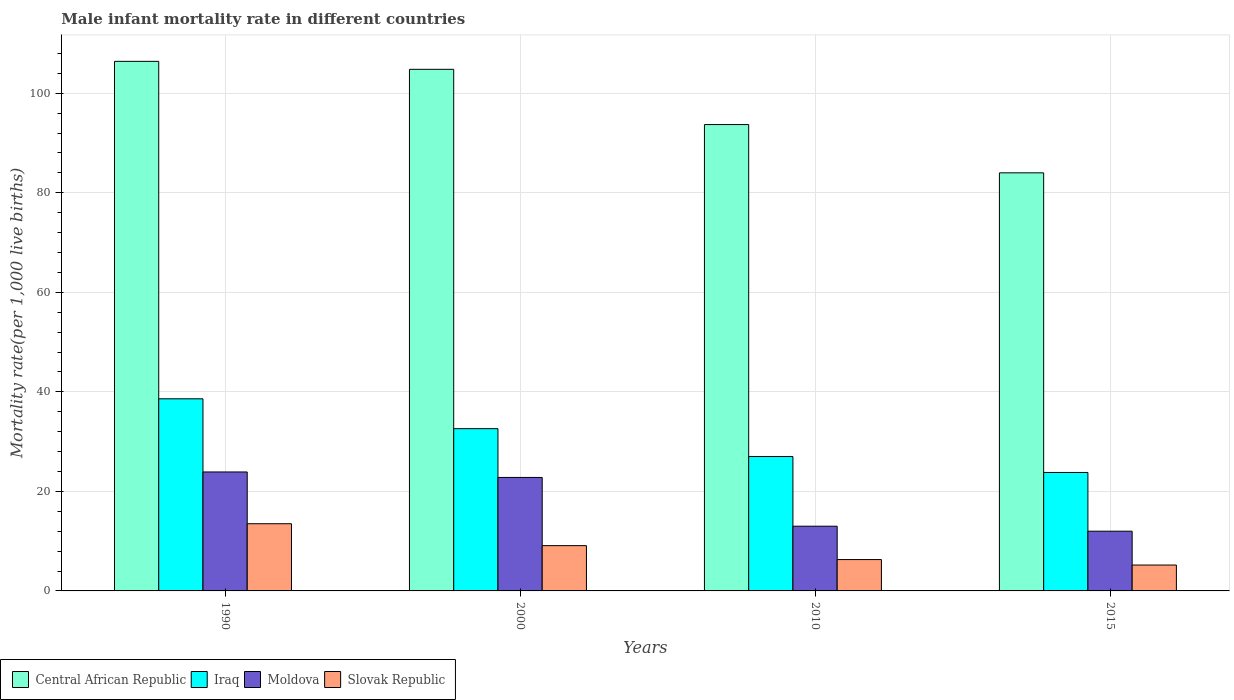How many groups of bars are there?
Your answer should be compact. 4. Are the number of bars per tick equal to the number of legend labels?
Keep it short and to the point. Yes. Are the number of bars on each tick of the X-axis equal?
Your answer should be compact. Yes. Across all years, what is the maximum male infant mortality rate in Moldova?
Your answer should be compact. 23.9. Across all years, what is the minimum male infant mortality rate in Iraq?
Offer a terse response. 23.8. In which year was the male infant mortality rate in Moldova minimum?
Provide a short and direct response. 2015. What is the total male infant mortality rate in Central African Republic in the graph?
Offer a very short reply. 388.9. What is the difference between the male infant mortality rate in Central African Republic in 2015 and the male infant mortality rate in Iraq in 1990?
Provide a short and direct response. 45.4. What is the average male infant mortality rate in Slovak Republic per year?
Your answer should be compact. 8.53. In the year 2010, what is the difference between the male infant mortality rate in Slovak Republic and male infant mortality rate in Moldova?
Your answer should be compact. -6.7. What is the ratio of the male infant mortality rate in Iraq in 1990 to that in 2000?
Your answer should be compact. 1.18. Is the male infant mortality rate in Central African Republic in 1990 less than that in 2000?
Your answer should be compact. No. What does the 2nd bar from the left in 1990 represents?
Ensure brevity in your answer.  Iraq. What does the 1st bar from the right in 1990 represents?
Ensure brevity in your answer.  Slovak Republic. Is it the case that in every year, the sum of the male infant mortality rate in Iraq and male infant mortality rate in Slovak Republic is greater than the male infant mortality rate in Central African Republic?
Ensure brevity in your answer.  No. How many bars are there?
Your answer should be very brief. 16. Are all the bars in the graph horizontal?
Ensure brevity in your answer.  No. How many years are there in the graph?
Offer a very short reply. 4. Are the values on the major ticks of Y-axis written in scientific E-notation?
Offer a terse response. No. Does the graph contain any zero values?
Ensure brevity in your answer.  No. Where does the legend appear in the graph?
Provide a succinct answer. Bottom left. How are the legend labels stacked?
Offer a terse response. Horizontal. What is the title of the graph?
Offer a very short reply. Male infant mortality rate in different countries. What is the label or title of the X-axis?
Provide a short and direct response. Years. What is the label or title of the Y-axis?
Offer a very short reply. Mortality rate(per 1,0 live births). What is the Mortality rate(per 1,000 live births) in Central African Republic in 1990?
Ensure brevity in your answer.  106.4. What is the Mortality rate(per 1,000 live births) of Iraq in 1990?
Ensure brevity in your answer.  38.6. What is the Mortality rate(per 1,000 live births) of Moldova in 1990?
Offer a terse response. 23.9. What is the Mortality rate(per 1,000 live births) in Central African Republic in 2000?
Your response must be concise. 104.8. What is the Mortality rate(per 1,000 live births) in Iraq in 2000?
Keep it short and to the point. 32.6. What is the Mortality rate(per 1,000 live births) in Moldova in 2000?
Ensure brevity in your answer.  22.8. What is the Mortality rate(per 1,000 live births) of Central African Republic in 2010?
Your response must be concise. 93.7. What is the Mortality rate(per 1,000 live births) in Iraq in 2010?
Your answer should be very brief. 27. What is the Mortality rate(per 1,000 live births) in Moldova in 2010?
Your answer should be very brief. 13. What is the Mortality rate(per 1,000 live births) of Central African Republic in 2015?
Offer a very short reply. 84. What is the Mortality rate(per 1,000 live births) in Iraq in 2015?
Make the answer very short. 23.8. What is the Mortality rate(per 1,000 live births) of Moldova in 2015?
Ensure brevity in your answer.  12. Across all years, what is the maximum Mortality rate(per 1,000 live births) in Central African Republic?
Your answer should be very brief. 106.4. Across all years, what is the maximum Mortality rate(per 1,000 live births) in Iraq?
Give a very brief answer. 38.6. Across all years, what is the maximum Mortality rate(per 1,000 live births) in Moldova?
Offer a very short reply. 23.9. Across all years, what is the maximum Mortality rate(per 1,000 live births) of Slovak Republic?
Keep it short and to the point. 13.5. Across all years, what is the minimum Mortality rate(per 1,000 live births) in Iraq?
Offer a terse response. 23.8. What is the total Mortality rate(per 1,000 live births) in Central African Republic in the graph?
Offer a terse response. 388.9. What is the total Mortality rate(per 1,000 live births) in Iraq in the graph?
Keep it short and to the point. 122. What is the total Mortality rate(per 1,000 live births) of Moldova in the graph?
Make the answer very short. 71.7. What is the total Mortality rate(per 1,000 live births) in Slovak Republic in the graph?
Ensure brevity in your answer.  34.1. What is the difference between the Mortality rate(per 1,000 live births) of Central African Republic in 1990 and that in 2000?
Ensure brevity in your answer.  1.6. What is the difference between the Mortality rate(per 1,000 live births) in Moldova in 1990 and that in 2000?
Your answer should be compact. 1.1. What is the difference between the Mortality rate(per 1,000 live births) of Central African Republic in 1990 and that in 2010?
Provide a short and direct response. 12.7. What is the difference between the Mortality rate(per 1,000 live births) in Moldova in 1990 and that in 2010?
Make the answer very short. 10.9. What is the difference between the Mortality rate(per 1,000 live births) in Slovak Republic in 1990 and that in 2010?
Keep it short and to the point. 7.2. What is the difference between the Mortality rate(per 1,000 live births) of Central African Republic in 1990 and that in 2015?
Give a very brief answer. 22.4. What is the difference between the Mortality rate(per 1,000 live births) of Central African Republic in 2000 and that in 2010?
Offer a terse response. 11.1. What is the difference between the Mortality rate(per 1,000 live births) in Slovak Republic in 2000 and that in 2010?
Provide a succinct answer. 2.8. What is the difference between the Mortality rate(per 1,000 live births) of Central African Republic in 2000 and that in 2015?
Provide a short and direct response. 20.8. What is the difference between the Mortality rate(per 1,000 live births) of Iraq in 2000 and that in 2015?
Your answer should be compact. 8.8. What is the difference between the Mortality rate(per 1,000 live births) of Slovak Republic in 2000 and that in 2015?
Provide a succinct answer. 3.9. What is the difference between the Mortality rate(per 1,000 live births) of Moldova in 2010 and that in 2015?
Make the answer very short. 1. What is the difference between the Mortality rate(per 1,000 live births) in Slovak Republic in 2010 and that in 2015?
Your answer should be very brief. 1.1. What is the difference between the Mortality rate(per 1,000 live births) in Central African Republic in 1990 and the Mortality rate(per 1,000 live births) in Iraq in 2000?
Give a very brief answer. 73.8. What is the difference between the Mortality rate(per 1,000 live births) in Central African Republic in 1990 and the Mortality rate(per 1,000 live births) in Moldova in 2000?
Offer a very short reply. 83.6. What is the difference between the Mortality rate(per 1,000 live births) of Central African Republic in 1990 and the Mortality rate(per 1,000 live births) of Slovak Republic in 2000?
Make the answer very short. 97.3. What is the difference between the Mortality rate(per 1,000 live births) in Iraq in 1990 and the Mortality rate(per 1,000 live births) in Moldova in 2000?
Offer a terse response. 15.8. What is the difference between the Mortality rate(per 1,000 live births) of Iraq in 1990 and the Mortality rate(per 1,000 live births) of Slovak Republic in 2000?
Your answer should be compact. 29.5. What is the difference between the Mortality rate(per 1,000 live births) in Central African Republic in 1990 and the Mortality rate(per 1,000 live births) in Iraq in 2010?
Your answer should be compact. 79.4. What is the difference between the Mortality rate(per 1,000 live births) of Central African Republic in 1990 and the Mortality rate(per 1,000 live births) of Moldova in 2010?
Offer a very short reply. 93.4. What is the difference between the Mortality rate(per 1,000 live births) in Central African Republic in 1990 and the Mortality rate(per 1,000 live births) in Slovak Republic in 2010?
Provide a succinct answer. 100.1. What is the difference between the Mortality rate(per 1,000 live births) in Iraq in 1990 and the Mortality rate(per 1,000 live births) in Moldova in 2010?
Provide a succinct answer. 25.6. What is the difference between the Mortality rate(per 1,000 live births) in Iraq in 1990 and the Mortality rate(per 1,000 live births) in Slovak Republic in 2010?
Give a very brief answer. 32.3. What is the difference between the Mortality rate(per 1,000 live births) of Moldova in 1990 and the Mortality rate(per 1,000 live births) of Slovak Republic in 2010?
Make the answer very short. 17.6. What is the difference between the Mortality rate(per 1,000 live births) of Central African Republic in 1990 and the Mortality rate(per 1,000 live births) of Iraq in 2015?
Make the answer very short. 82.6. What is the difference between the Mortality rate(per 1,000 live births) of Central African Republic in 1990 and the Mortality rate(per 1,000 live births) of Moldova in 2015?
Keep it short and to the point. 94.4. What is the difference between the Mortality rate(per 1,000 live births) in Central African Republic in 1990 and the Mortality rate(per 1,000 live births) in Slovak Republic in 2015?
Your answer should be compact. 101.2. What is the difference between the Mortality rate(per 1,000 live births) of Iraq in 1990 and the Mortality rate(per 1,000 live births) of Moldova in 2015?
Provide a succinct answer. 26.6. What is the difference between the Mortality rate(per 1,000 live births) in Iraq in 1990 and the Mortality rate(per 1,000 live births) in Slovak Republic in 2015?
Offer a terse response. 33.4. What is the difference between the Mortality rate(per 1,000 live births) in Moldova in 1990 and the Mortality rate(per 1,000 live births) in Slovak Republic in 2015?
Offer a terse response. 18.7. What is the difference between the Mortality rate(per 1,000 live births) of Central African Republic in 2000 and the Mortality rate(per 1,000 live births) of Iraq in 2010?
Your answer should be compact. 77.8. What is the difference between the Mortality rate(per 1,000 live births) of Central African Republic in 2000 and the Mortality rate(per 1,000 live births) of Moldova in 2010?
Give a very brief answer. 91.8. What is the difference between the Mortality rate(per 1,000 live births) in Central African Republic in 2000 and the Mortality rate(per 1,000 live births) in Slovak Republic in 2010?
Your response must be concise. 98.5. What is the difference between the Mortality rate(per 1,000 live births) in Iraq in 2000 and the Mortality rate(per 1,000 live births) in Moldova in 2010?
Your answer should be compact. 19.6. What is the difference between the Mortality rate(per 1,000 live births) of Iraq in 2000 and the Mortality rate(per 1,000 live births) of Slovak Republic in 2010?
Give a very brief answer. 26.3. What is the difference between the Mortality rate(per 1,000 live births) of Central African Republic in 2000 and the Mortality rate(per 1,000 live births) of Iraq in 2015?
Provide a short and direct response. 81. What is the difference between the Mortality rate(per 1,000 live births) in Central African Republic in 2000 and the Mortality rate(per 1,000 live births) in Moldova in 2015?
Provide a succinct answer. 92.8. What is the difference between the Mortality rate(per 1,000 live births) in Central African Republic in 2000 and the Mortality rate(per 1,000 live births) in Slovak Republic in 2015?
Make the answer very short. 99.6. What is the difference between the Mortality rate(per 1,000 live births) in Iraq in 2000 and the Mortality rate(per 1,000 live births) in Moldova in 2015?
Give a very brief answer. 20.6. What is the difference between the Mortality rate(per 1,000 live births) of Iraq in 2000 and the Mortality rate(per 1,000 live births) of Slovak Republic in 2015?
Offer a very short reply. 27.4. What is the difference between the Mortality rate(per 1,000 live births) of Moldova in 2000 and the Mortality rate(per 1,000 live births) of Slovak Republic in 2015?
Keep it short and to the point. 17.6. What is the difference between the Mortality rate(per 1,000 live births) of Central African Republic in 2010 and the Mortality rate(per 1,000 live births) of Iraq in 2015?
Give a very brief answer. 69.9. What is the difference between the Mortality rate(per 1,000 live births) of Central African Republic in 2010 and the Mortality rate(per 1,000 live births) of Moldova in 2015?
Give a very brief answer. 81.7. What is the difference between the Mortality rate(per 1,000 live births) in Central African Republic in 2010 and the Mortality rate(per 1,000 live births) in Slovak Republic in 2015?
Ensure brevity in your answer.  88.5. What is the difference between the Mortality rate(per 1,000 live births) in Iraq in 2010 and the Mortality rate(per 1,000 live births) in Slovak Republic in 2015?
Give a very brief answer. 21.8. What is the average Mortality rate(per 1,000 live births) in Central African Republic per year?
Offer a very short reply. 97.22. What is the average Mortality rate(per 1,000 live births) in Iraq per year?
Provide a succinct answer. 30.5. What is the average Mortality rate(per 1,000 live births) in Moldova per year?
Give a very brief answer. 17.93. What is the average Mortality rate(per 1,000 live births) of Slovak Republic per year?
Keep it short and to the point. 8.53. In the year 1990, what is the difference between the Mortality rate(per 1,000 live births) of Central African Republic and Mortality rate(per 1,000 live births) of Iraq?
Give a very brief answer. 67.8. In the year 1990, what is the difference between the Mortality rate(per 1,000 live births) in Central African Republic and Mortality rate(per 1,000 live births) in Moldova?
Ensure brevity in your answer.  82.5. In the year 1990, what is the difference between the Mortality rate(per 1,000 live births) in Central African Republic and Mortality rate(per 1,000 live births) in Slovak Republic?
Provide a short and direct response. 92.9. In the year 1990, what is the difference between the Mortality rate(per 1,000 live births) of Iraq and Mortality rate(per 1,000 live births) of Slovak Republic?
Offer a very short reply. 25.1. In the year 2000, what is the difference between the Mortality rate(per 1,000 live births) of Central African Republic and Mortality rate(per 1,000 live births) of Iraq?
Provide a succinct answer. 72.2. In the year 2000, what is the difference between the Mortality rate(per 1,000 live births) in Central African Republic and Mortality rate(per 1,000 live births) in Slovak Republic?
Provide a short and direct response. 95.7. In the year 2000, what is the difference between the Mortality rate(per 1,000 live births) in Iraq and Mortality rate(per 1,000 live births) in Moldova?
Offer a terse response. 9.8. In the year 2010, what is the difference between the Mortality rate(per 1,000 live births) in Central African Republic and Mortality rate(per 1,000 live births) in Iraq?
Your response must be concise. 66.7. In the year 2010, what is the difference between the Mortality rate(per 1,000 live births) of Central African Republic and Mortality rate(per 1,000 live births) of Moldova?
Keep it short and to the point. 80.7. In the year 2010, what is the difference between the Mortality rate(per 1,000 live births) of Central African Republic and Mortality rate(per 1,000 live births) of Slovak Republic?
Your answer should be compact. 87.4. In the year 2010, what is the difference between the Mortality rate(per 1,000 live births) in Iraq and Mortality rate(per 1,000 live births) in Slovak Republic?
Ensure brevity in your answer.  20.7. In the year 2015, what is the difference between the Mortality rate(per 1,000 live births) of Central African Republic and Mortality rate(per 1,000 live births) of Iraq?
Offer a very short reply. 60.2. In the year 2015, what is the difference between the Mortality rate(per 1,000 live births) of Central African Republic and Mortality rate(per 1,000 live births) of Moldova?
Give a very brief answer. 72. In the year 2015, what is the difference between the Mortality rate(per 1,000 live births) in Central African Republic and Mortality rate(per 1,000 live births) in Slovak Republic?
Ensure brevity in your answer.  78.8. In the year 2015, what is the difference between the Mortality rate(per 1,000 live births) of Iraq and Mortality rate(per 1,000 live births) of Moldova?
Offer a terse response. 11.8. What is the ratio of the Mortality rate(per 1,000 live births) of Central African Republic in 1990 to that in 2000?
Give a very brief answer. 1.02. What is the ratio of the Mortality rate(per 1,000 live births) of Iraq in 1990 to that in 2000?
Provide a succinct answer. 1.18. What is the ratio of the Mortality rate(per 1,000 live births) in Moldova in 1990 to that in 2000?
Your response must be concise. 1.05. What is the ratio of the Mortality rate(per 1,000 live births) in Slovak Republic in 1990 to that in 2000?
Your answer should be very brief. 1.48. What is the ratio of the Mortality rate(per 1,000 live births) in Central African Republic in 1990 to that in 2010?
Offer a terse response. 1.14. What is the ratio of the Mortality rate(per 1,000 live births) of Iraq in 1990 to that in 2010?
Provide a succinct answer. 1.43. What is the ratio of the Mortality rate(per 1,000 live births) of Moldova in 1990 to that in 2010?
Your response must be concise. 1.84. What is the ratio of the Mortality rate(per 1,000 live births) in Slovak Republic in 1990 to that in 2010?
Give a very brief answer. 2.14. What is the ratio of the Mortality rate(per 1,000 live births) in Central African Republic in 1990 to that in 2015?
Give a very brief answer. 1.27. What is the ratio of the Mortality rate(per 1,000 live births) of Iraq in 1990 to that in 2015?
Offer a terse response. 1.62. What is the ratio of the Mortality rate(per 1,000 live births) of Moldova in 1990 to that in 2015?
Offer a terse response. 1.99. What is the ratio of the Mortality rate(per 1,000 live births) in Slovak Republic in 1990 to that in 2015?
Offer a terse response. 2.6. What is the ratio of the Mortality rate(per 1,000 live births) of Central African Republic in 2000 to that in 2010?
Make the answer very short. 1.12. What is the ratio of the Mortality rate(per 1,000 live births) in Iraq in 2000 to that in 2010?
Provide a succinct answer. 1.21. What is the ratio of the Mortality rate(per 1,000 live births) in Moldova in 2000 to that in 2010?
Ensure brevity in your answer.  1.75. What is the ratio of the Mortality rate(per 1,000 live births) of Slovak Republic in 2000 to that in 2010?
Offer a very short reply. 1.44. What is the ratio of the Mortality rate(per 1,000 live births) in Central African Republic in 2000 to that in 2015?
Your answer should be compact. 1.25. What is the ratio of the Mortality rate(per 1,000 live births) in Iraq in 2000 to that in 2015?
Make the answer very short. 1.37. What is the ratio of the Mortality rate(per 1,000 live births) in Slovak Republic in 2000 to that in 2015?
Your answer should be very brief. 1.75. What is the ratio of the Mortality rate(per 1,000 live births) of Central African Republic in 2010 to that in 2015?
Your answer should be compact. 1.12. What is the ratio of the Mortality rate(per 1,000 live births) of Iraq in 2010 to that in 2015?
Make the answer very short. 1.13. What is the ratio of the Mortality rate(per 1,000 live births) in Moldova in 2010 to that in 2015?
Keep it short and to the point. 1.08. What is the ratio of the Mortality rate(per 1,000 live births) in Slovak Republic in 2010 to that in 2015?
Ensure brevity in your answer.  1.21. What is the difference between the highest and the second highest Mortality rate(per 1,000 live births) of Moldova?
Offer a terse response. 1.1. What is the difference between the highest and the lowest Mortality rate(per 1,000 live births) in Central African Republic?
Your answer should be compact. 22.4. What is the difference between the highest and the lowest Mortality rate(per 1,000 live births) of Iraq?
Your response must be concise. 14.8. What is the difference between the highest and the lowest Mortality rate(per 1,000 live births) in Moldova?
Ensure brevity in your answer.  11.9. 